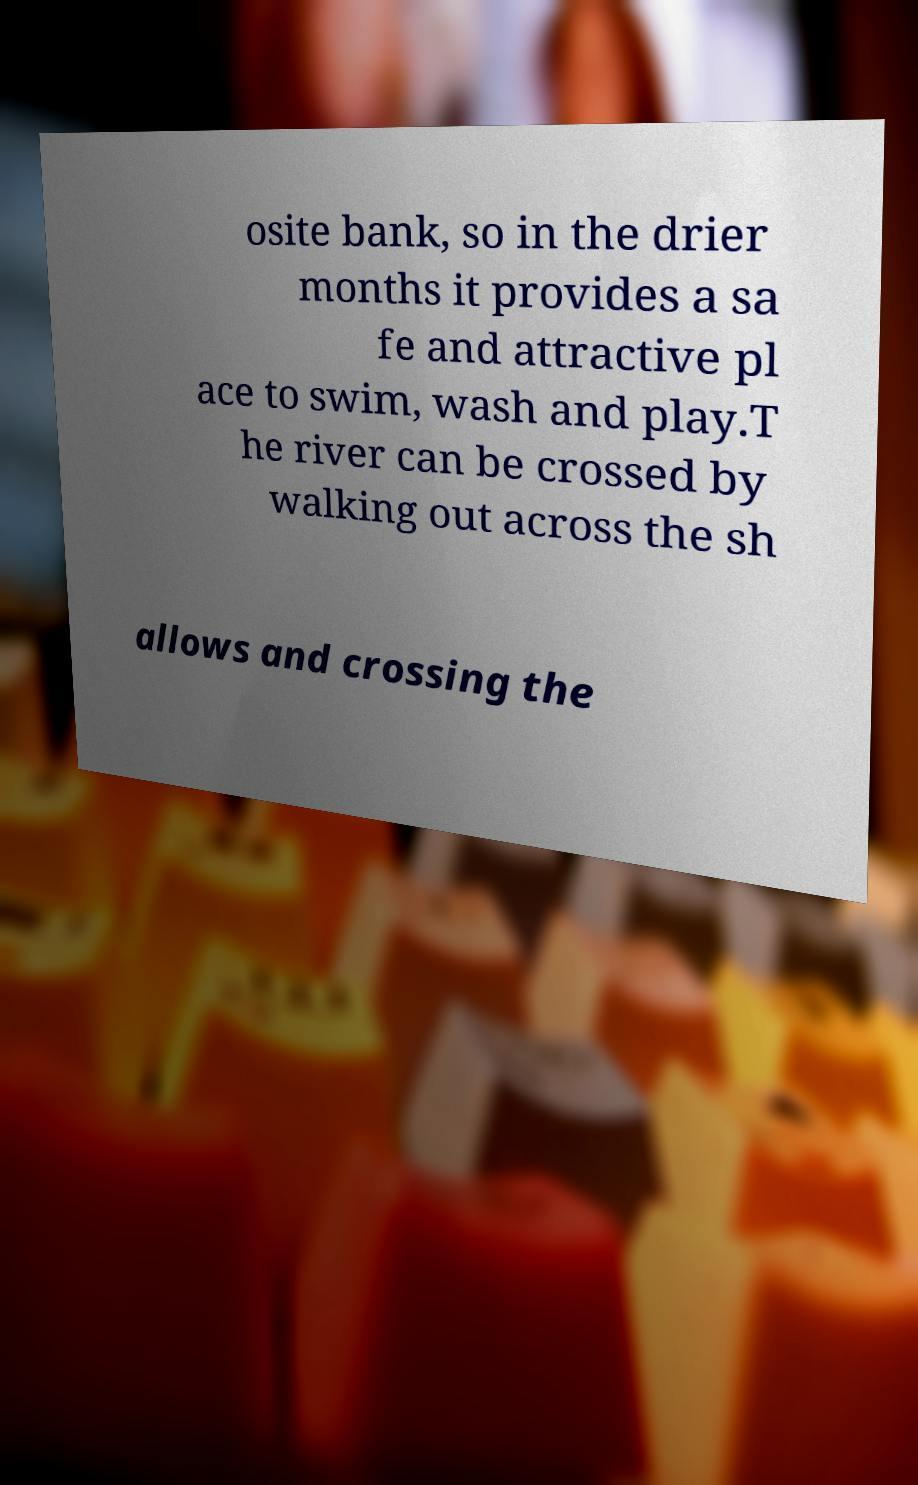I need the written content from this picture converted into text. Can you do that? osite bank, so in the drier months it provides a sa fe and attractive pl ace to swim, wash and play.T he river can be crossed by walking out across the sh allows and crossing the 